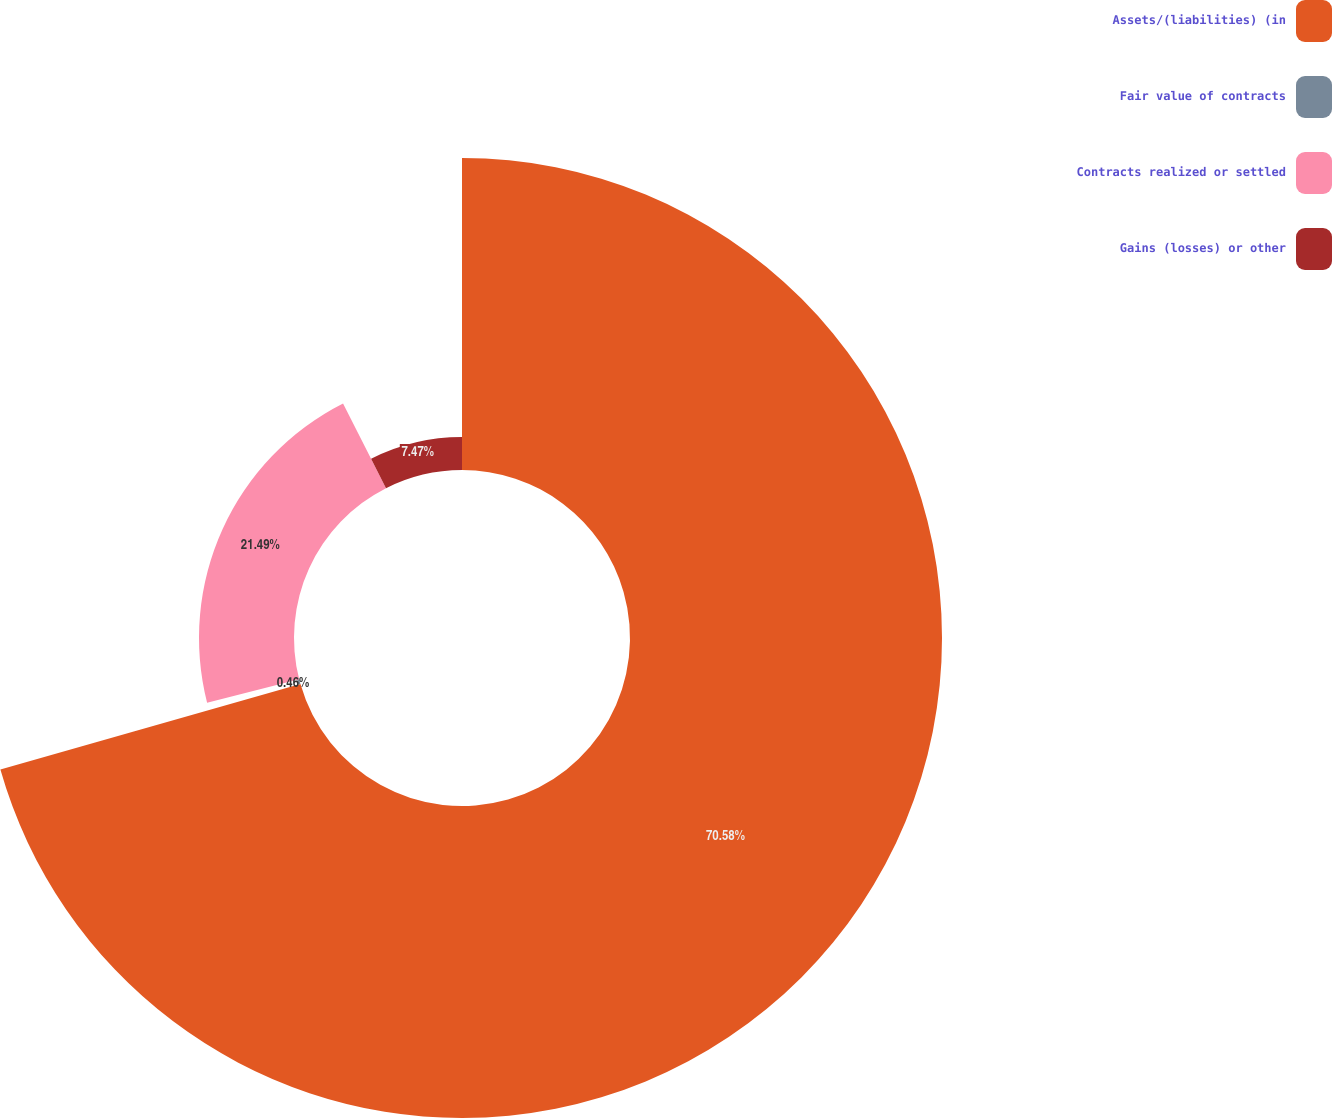<chart> <loc_0><loc_0><loc_500><loc_500><pie_chart><fcel>Assets/(liabilities) (in<fcel>Fair value of contracts<fcel>Contracts realized or settled<fcel>Gains (losses) or other<nl><fcel>70.58%<fcel>0.46%<fcel>21.49%<fcel>7.47%<nl></chart> 